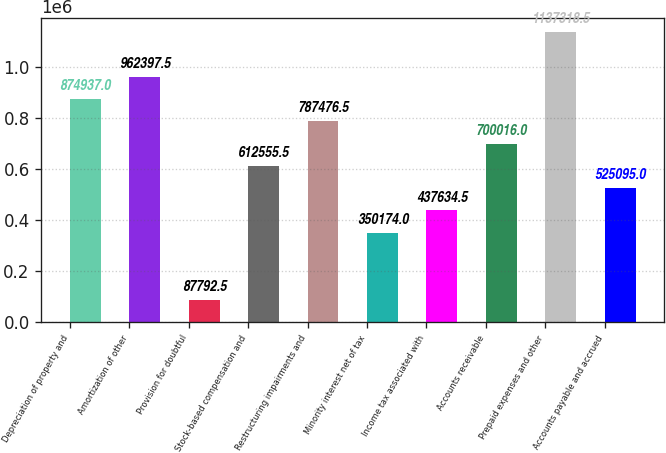<chart> <loc_0><loc_0><loc_500><loc_500><bar_chart><fcel>Depreciation of property and<fcel>Amortization of other<fcel>Provision for doubtful<fcel>Stock-based compensation and<fcel>Restructuring impairments and<fcel>Minority interest net of tax<fcel>Income tax associated with<fcel>Accounts receivable<fcel>Prepaid expenses and other<fcel>Accounts payable and accrued<nl><fcel>874937<fcel>962398<fcel>87792.5<fcel>612556<fcel>787476<fcel>350174<fcel>437634<fcel>700016<fcel>1.13732e+06<fcel>525095<nl></chart> 